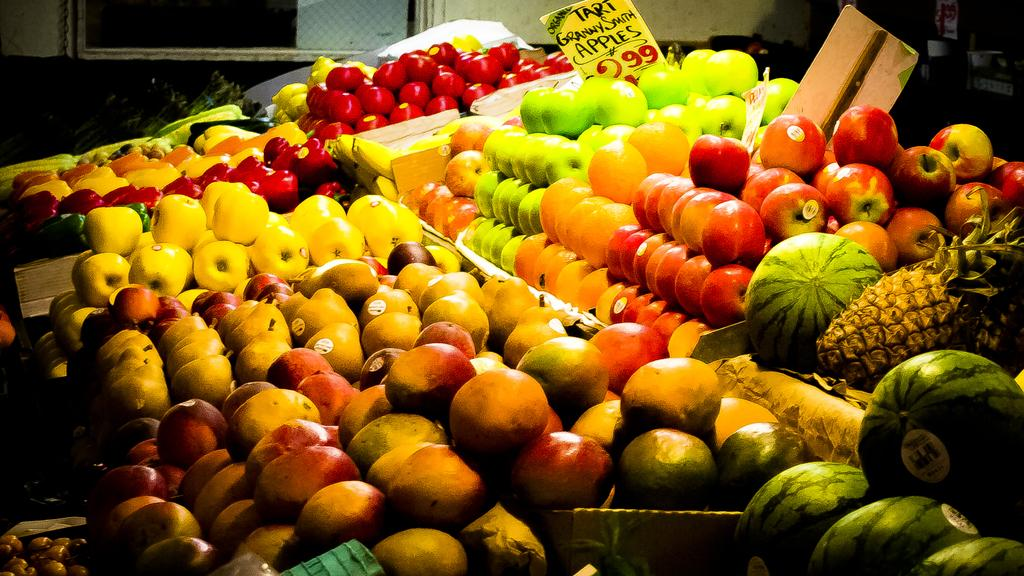What types of fruits can be seen in the image? There are apples, watermelons, a pineapple, and other fruits in the image. How are the fruits arranged or displayed in the image? The fruits are placed on plates in the image. Are there any other objects or elements visible in the image? Yes, there are boards visible in the image. What type of railway system is visible in the image? There is no railway system present in the image; it features fruits on plates and boards. How does the brake function on the watermelon in the image? There is no brake on the watermelon or any other fruit in the image; it is a fruit and not a vehicle. 